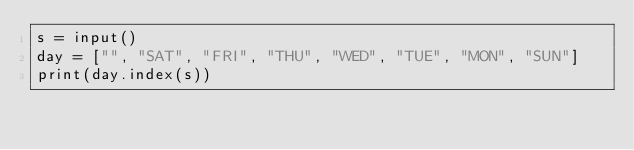Convert code to text. <code><loc_0><loc_0><loc_500><loc_500><_Python_>s = input()
day = ["", "SAT", "FRI", "THU", "WED", "TUE", "MON", "SUN"]
print(day.index(s))</code> 